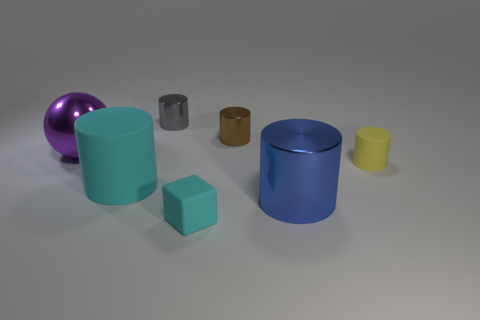Are there any small purple metallic objects that have the same shape as the small gray object?
Keep it short and to the point. No. Is there a large metal sphere that is in front of the object to the right of the blue object?
Your response must be concise. No. How many tiny brown cylinders have the same material as the purple thing?
Make the answer very short. 1. Are any large red cubes visible?
Offer a terse response. No. What number of large metallic things are the same color as the big rubber thing?
Your response must be concise. 0. Is the material of the yellow object the same as the large cylinder that is on the right side of the cyan cylinder?
Make the answer very short. No. Is the number of large cyan rubber objects that are in front of the blue metallic thing greater than the number of yellow things?
Offer a terse response. No. There is a big sphere; is its color the same as the large shiny object that is to the right of the big purple ball?
Offer a terse response. No. Is the number of small blocks behind the large purple sphere the same as the number of large things behind the big metal cylinder?
Your answer should be compact. No. What is the material of the small object that is to the left of the small cyan matte block?
Make the answer very short. Metal. 